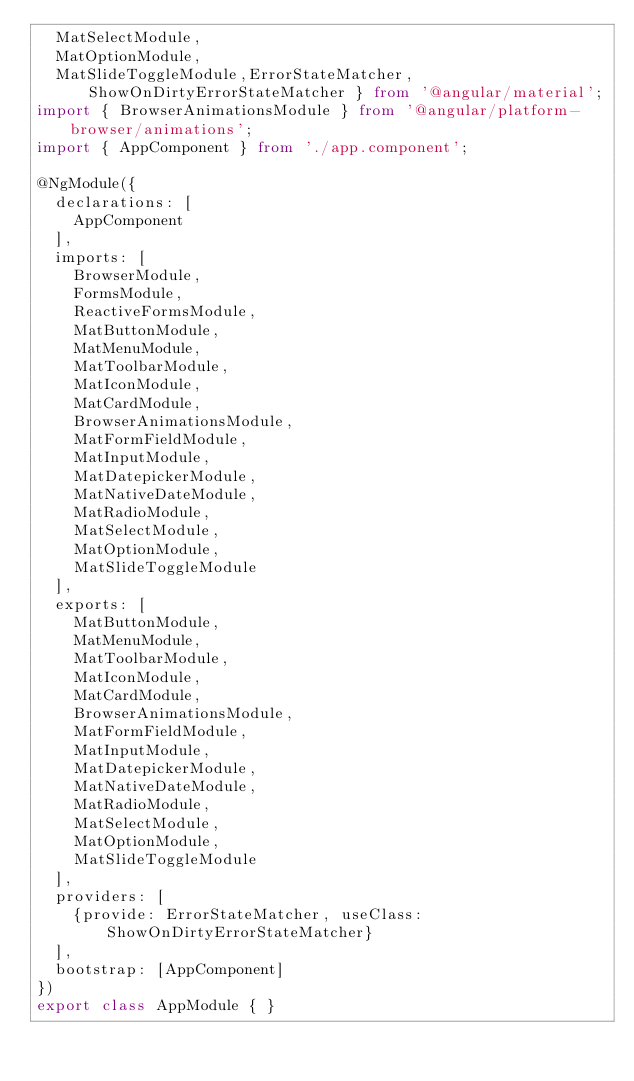Convert code to text. <code><loc_0><loc_0><loc_500><loc_500><_TypeScript_>  MatSelectModule,  
  MatOptionModule,  
  MatSlideToggleModule,ErrorStateMatcher,ShowOnDirtyErrorStateMatcher } from '@angular/material';  
import { BrowserAnimationsModule } from '@angular/platform-browser/animations';  
import { AppComponent } from './app.component';  
  
@NgModule({  
  declarations: [  
    AppComponent  
  ],  
  imports: [  
    BrowserModule,  
    FormsModule,  
    ReactiveFormsModule,  
    MatButtonModule,  
    MatMenuModule,  
    MatToolbarModule,  
    MatIconModule,  
    MatCardModule,  
    BrowserAnimationsModule,  
    MatFormFieldModule,  
    MatInputModule,  
    MatDatepickerModule,  
    MatNativeDateModule,  
    MatRadioModule,  
    MatSelectModule,  
    MatOptionModule,  
    MatSlideToggleModule  
  ],  
  exports: [  
    MatButtonModule,  
    MatMenuModule,  
    MatToolbarModule,  
    MatIconModule,  
    MatCardModule,  
    BrowserAnimationsModule,  
    MatFormFieldModule,  
    MatInputModule,  
    MatDatepickerModule,  
    MatNativeDateModule,  
    MatRadioModule,  
    MatSelectModule,  
    MatOptionModule,  
    MatSlideToggleModule  
  ],  
  providers: [  
    {provide: ErrorStateMatcher, useClass: ShowOnDirtyErrorStateMatcher}  
  ],  
  bootstrap: [AppComponent]  
})  
export class AppModule { }  </code> 